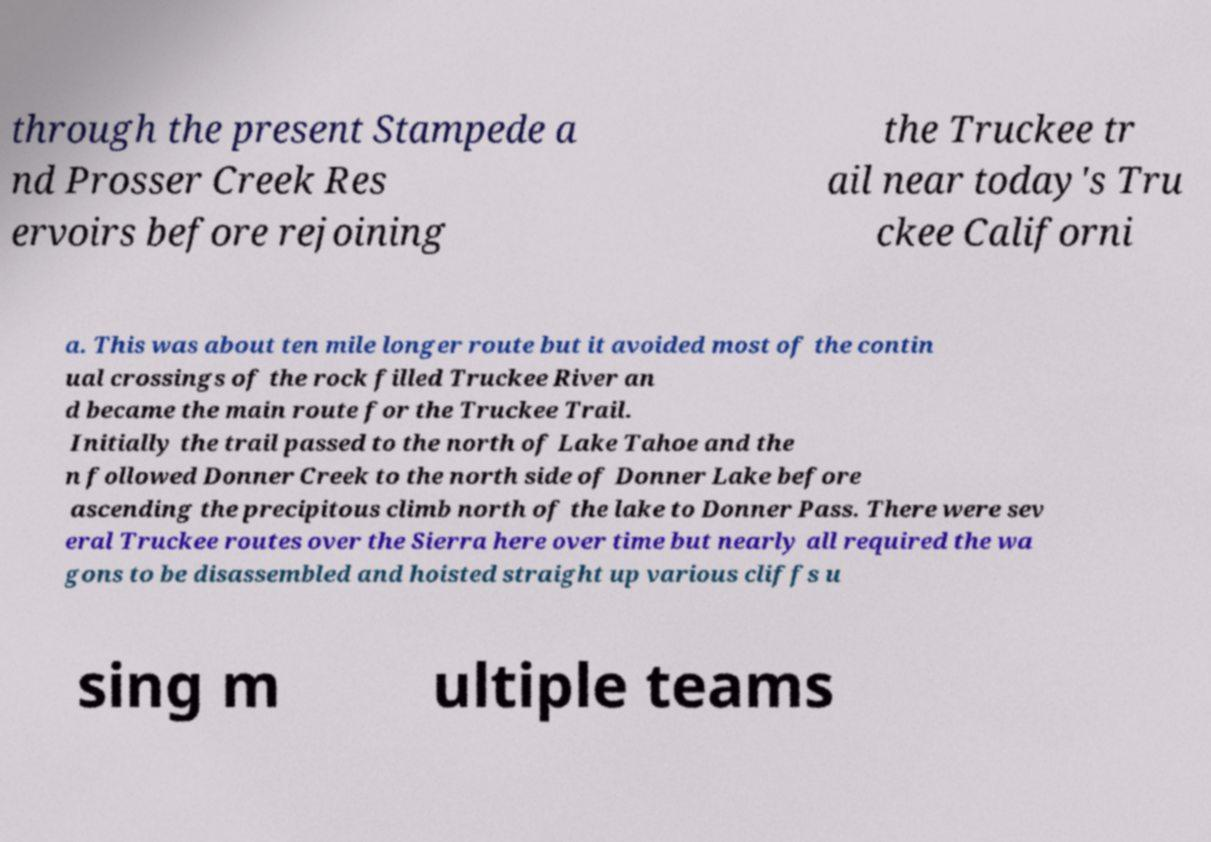There's text embedded in this image that I need extracted. Can you transcribe it verbatim? through the present Stampede a nd Prosser Creek Res ervoirs before rejoining the Truckee tr ail near today's Tru ckee Californi a. This was about ten mile longer route but it avoided most of the contin ual crossings of the rock filled Truckee River an d became the main route for the Truckee Trail. Initially the trail passed to the north of Lake Tahoe and the n followed Donner Creek to the north side of Donner Lake before ascending the precipitous climb north of the lake to Donner Pass. There were sev eral Truckee routes over the Sierra here over time but nearly all required the wa gons to be disassembled and hoisted straight up various cliffs u sing m ultiple teams 